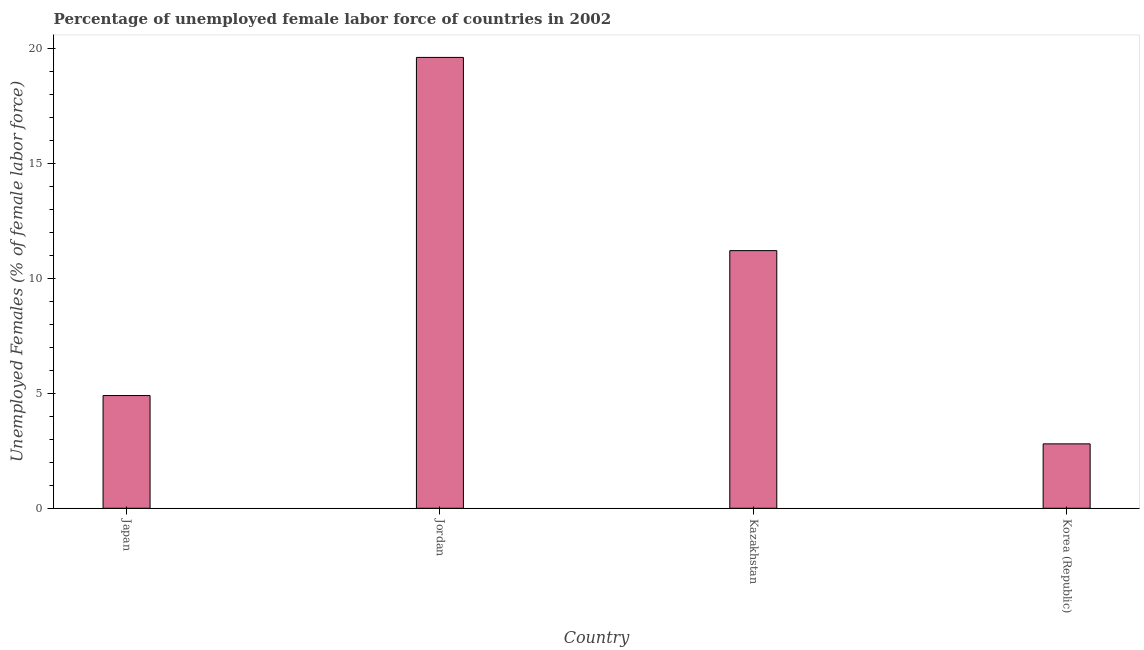Does the graph contain grids?
Give a very brief answer. No. What is the title of the graph?
Make the answer very short. Percentage of unemployed female labor force of countries in 2002. What is the label or title of the Y-axis?
Keep it short and to the point. Unemployed Females (% of female labor force). What is the total unemployed female labour force in Jordan?
Your answer should be very brief. 19.6. Across all countries, what is the maximum total unemployed female labour force?
Your response must be concise. 19.6. Across all countries, what is the minimum total unemployed female labour force?
Provide a succinct answer. 2.8. In which country was the total unemployed female labour force maximum?
Provide a short and direct response. Jordan. In which country was the total unemployed female labour force minimum?
Give a very brief answer. Korea (Republic). What is the sum of the total unemployed female labour force?
Make the answer very short. 38.5. What is the difference between the total unemployed female labour force in Jordan and Kazakhstan?
Ensure brevity in your answer.  8.4. What is the average total unemployed female labour force per country?
Keep it short and to the point. 9.62. What is the median total unemployed female labour force?
Provide a succinct answer. 8.05. Is the total unemployed female labour force in Japan less than that in Jordan?
Give a very brief answer. Yes. Is the difference between the total unemployed female labour force in Jordan and Kazakhstan greater than the difference between any two countries?
Ensure brevity in your answer.  No. What is the difference between the highest and the second highest total unemployed female labour force?
Offer a terse response. 8.4. Is the sum of the total unemployed female labour force in Japan and Korea (Republic) greater than the maximum total unemployed female labour force across all countries?
Your answer should be very brief. No. What is the difference between the highest and the lowest total unemployed female labour force?
Provide a short and direct response. 16.8. In how many countries, is the total unemployed female labour force greater than the average total unemployed female labour force taken over all countries?
Offer a very short reply. 2. How many bars are there?
Ensure brevity in your answer.  4. Are all the bars in the graph horizontal?
Ensure brevity in your answer.  No. What is the difference between two consecutive major ticks on the Y-axis?
Offer a very short reply. 5. Are the values on the major ticks of Y-axis written in scientific E-notation?
Your response must be concise. No. What is the Unemployed Females (% of female labor force) of Japan?
Offer a terse response. 4.9. What is the Unemployed Females (% of female labor force) of Jordan?
Your response must be concise. 19.6. What is the Unemployed Females (% of female labor force) of Kazakhstan?
Your answer should be compact. 11.2. What is the Unemployed Females (% of female labor force) of Korea (Republic)?
Offer a terse response. 2.8. What is the difference between the Unemployed Females (% of female labor force) in Japan and Jordan?
Your response must be concise. -14.7. What is the difference between the Unemployed Females (% of female labor force) in Japan and Korea (Republic)?
Give a very brief answer. 2.1. What is the difference between the Unemployed Females (% of female labor force) in Kazakhstan and Korea (Republic)?
Your answer should be compact. 8.4. What is the ratio of the Unemployed Females (% of female labor force) in Japan to that in Jordan?
Offer a very short reply. 0.25. What is the ratio of the Unemployed Females (% of female labor force) in Japan to that in Kazakhstan?
Your answer should be very brief. 0.44. What is the ratio of the Unemployed Females (% of female labor force) in Japan to that in Korea (Republic)?
Your answer should be compact. 1.75. What is the ratio of the Unemployed Females (% of female labor force) in Jordan to that in Kazakhstan?
Offer a terse response. 1.75. What is the ratio of the Unemployed Females (% of female labor force) in Kazakhstan to that in Korea (Republic)?
Your response must be concise. 4. 